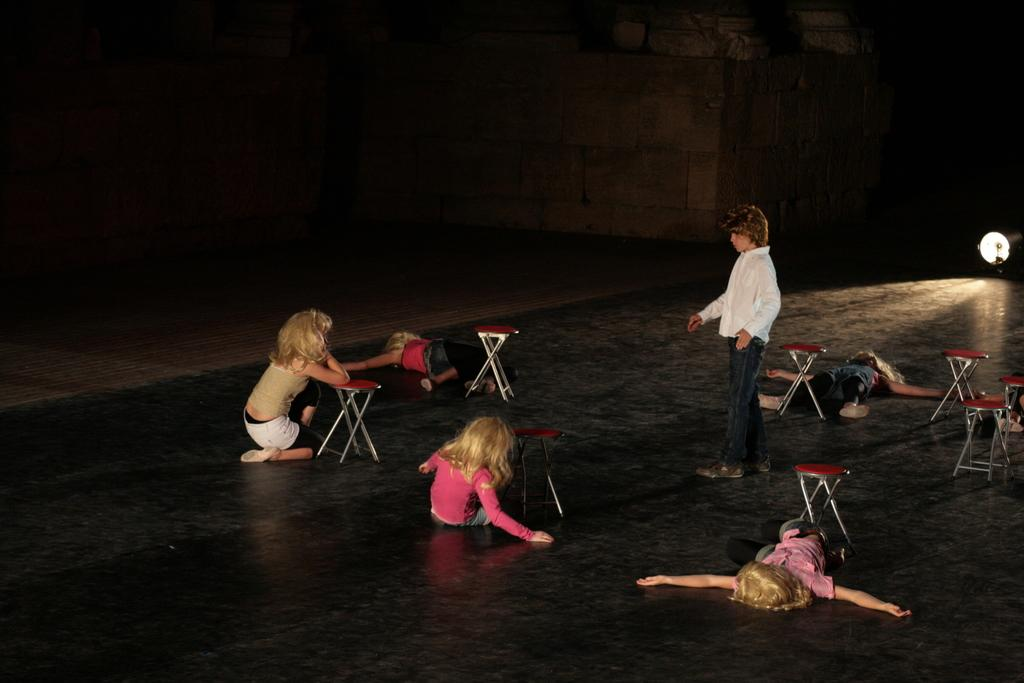How many kids are lying on the road in the image? There are three kids lying on the road in the image. What are the other positions of the kids in the image? Two kids are sitting on the floor, and one kid is standing. What objects are in front of the kids? There are stools in front of the kids. What type of secretary can be seen working in the image? There is no secretary present in the image; it features kids lying, sitting, and standing on the road. What is the cause of the kids' positions in the image? The facts provided do not give information about the cause of the kids' positions in the image. 